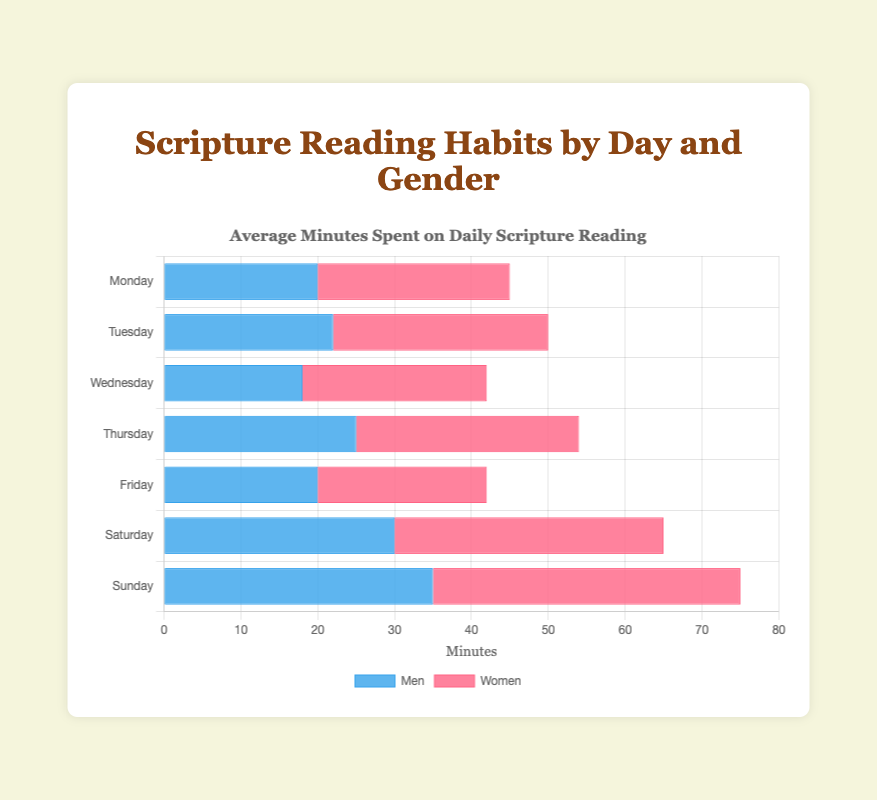Which day has the highest scripture reading time for men? The bar that extends the farthest on the graph for men (represented in blue) indicates the highest reading time for men. Referring to the length of the blue bars, Sunday has the longest bar for men.
Answer: Sunday Which day has the lowest scripture reading time for women? The bar that extends the shortest on the graph for women (represented in red) indicates the lowest reading time for women. Referring to the length of the red bars, Friday has the shortest bar for women.
Answer: Friday On which days do women spend more time reading scripture than men? By observing the length of the red bars relative to the blue bars on each corresponding day, women spend more time reading scripture on Monday, Tuesday, Wednesday, Thursday, Saturday, and Sunday. The red bar exceeds or is equal in length each of those days' blue bar.
Answer: Monday, Tuesday, Wednesday, Thursday, Saturday, Sunday How much more time do women spend reading scriptures on Thursday compared to Wednesday? On Thursday, women spend 29 minutes and on Wednesday, women spend 24 minutes. The difference is calculated as 29 - 24.
Answer: 5 minutes What is the total scripture reading time by men and women combined on Sunday? On Sunday, men read for 35 minutes and women read for 40 minutes. Their combined reading time is 35 + 40.
Answer: 75 minutes Which day has the smallest difference in scripture reading times between men and women? Calculate the absolute differences for each day: Monday (5), Tuesday (6), Wednesday (6), Thursday (4), Friday (2), Saturday (5), Sunday (5). The smallest difference is on Friday.
Answer: Friday What is the average scripture reading time for men across the week? Sum all men's reading times: 20 + 22 + 18 + 25 + 20 + 30 + 35 and divide by 7. The sum is 170, and the average is 170/7.
Answer: 24.29 minutes How much more time do women spend reading scriptures in total throughout the week compared to men? Sum women's reading times: 25 + 28 + 24 + 29 + 22 + 35 + 40 which is 203. Sum men's reading times: 170. The difference is calculated as 203 - 170.
Answer: 33 minutes Which gender spent more time reading scriptures on Tuesday? Compare the length of the bars for Tuesday. Women (red bar) read for 28 minutes, which is more than men (blue bar) reading for 22 minutes.
Answer: Women Which day has the highest combined scripture reading time? Add the reading times for both men and women for each day and compare. Sunday has the highest combined reading time of 75 minutes.
Answer: Sunday 